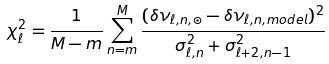<formula> <loc_0><loc_0><loc_500><loc_500>\chi ^ { 2 } _ { \ell } = \frac { 1 } { M - m } \sum _ { n = m } ^ { M } \frac { ( \delta \nu _ { { \ell , { n } } , \odot } - \delta \nu _ { { \ell , { n , m o d e l } } } ) ^ { 2 } } { \sigma ^ { 2 } _ { { \ell , { n } } } + \sigma ^ { 2 } _ { { \ell + 2 , { n - 1 } } } }</formula> 